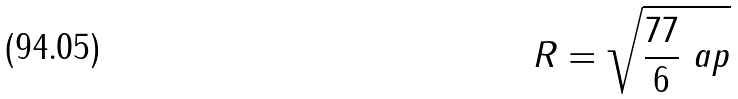<formula> <loc_0><loc_0><loc_500><loc_500>R = \sqrt { \frac { 7 7 } { 6 } \ a p }</formula> 